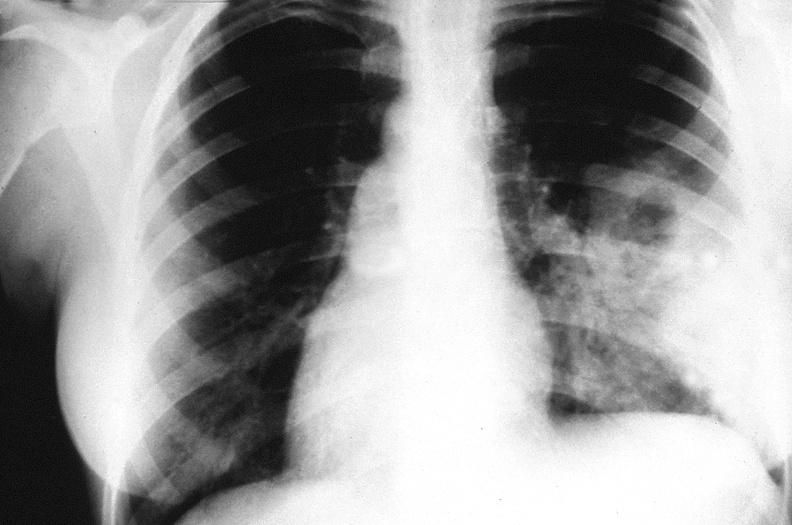does this image show chest x-ray, cryptococcal pneumonia?
Answer the question using a single word or phrase. Yes 